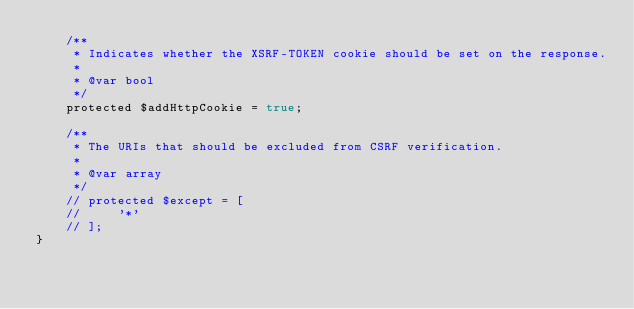Convert code to text. <code><loc_0><loc_0><loc_500><loc_500><_PHP_>    /**
     * Indicates whether the XSRF-TOKEN cookie should be set on the response.
     *
     * @var bool
     */
    protected $addHttpCookie = true;

    /**
     * The URIs that should be excluded from CSRF verification.
     *
     * @var array
     */
    // protected $except = [
    //     '*'
    // ];
}
</code> 